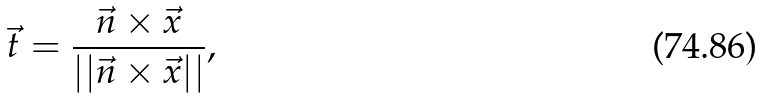<formula> <loc_0><loc_0><loc_500><loc_500>\vec { t } = \frac { \vec { n } \times \vec { x } } { | | \vec { n } \times \vec { x } | | } ,</formula> 